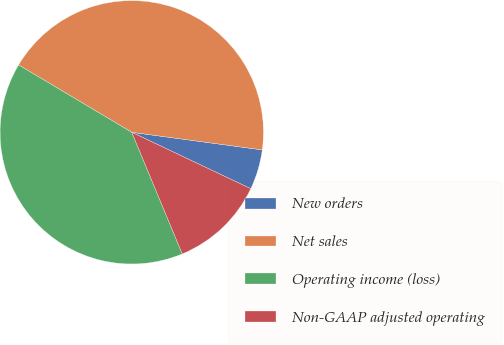<chart> <loc_0><loc_0><loc_500><loc_500><pie_chart><fcel>New orders<fcel>Net sales<fcel>Operating income (loss)<fcel>Non-GAAP adjusted operating<nl><fcel>4.91%<fcel>43.59%<fcel>39.81%<fcel>11.69%<nl></chart> 